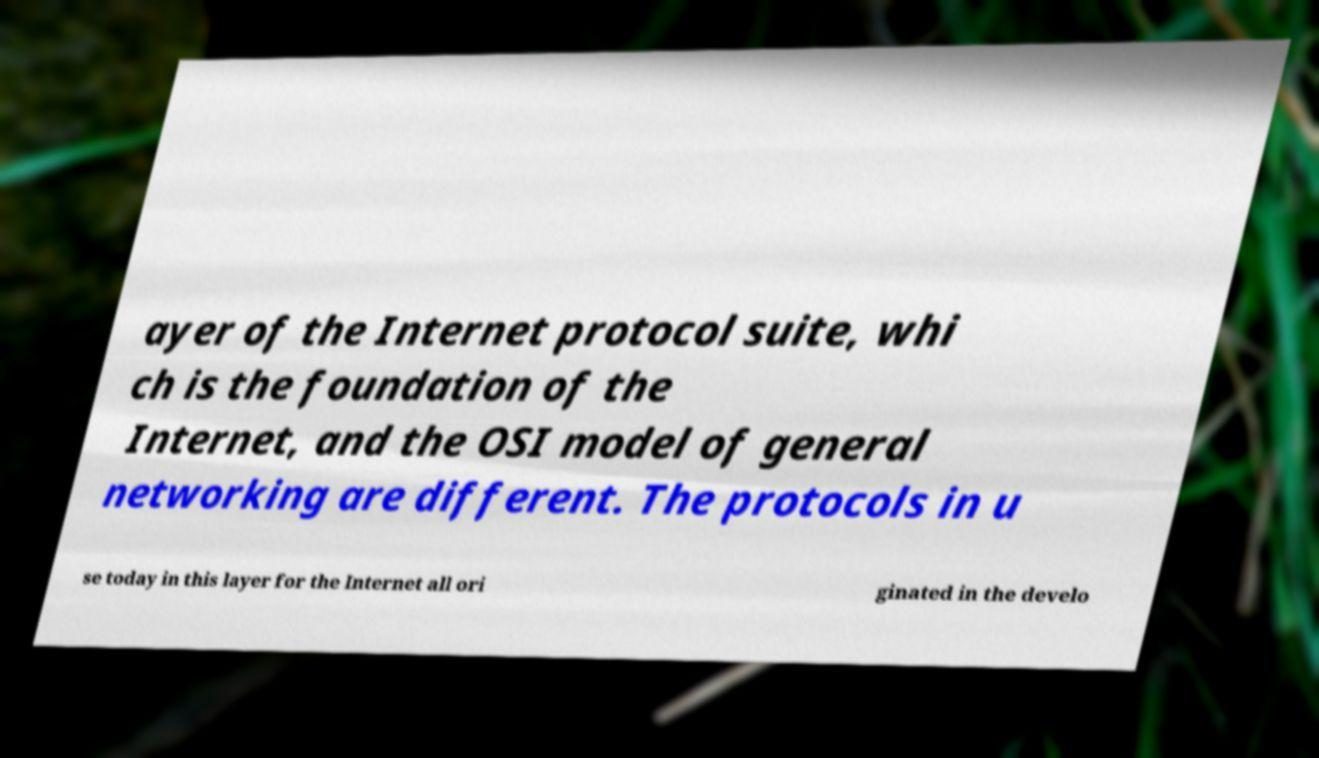Please identify and transcribe the text found in this image. ayer of the Internet protocol suite, whi ch is the foundation of the Internet, and the OSI model of general networking are different. The protocols in u se today in this layer for the Internet all ori ginated in the develo 